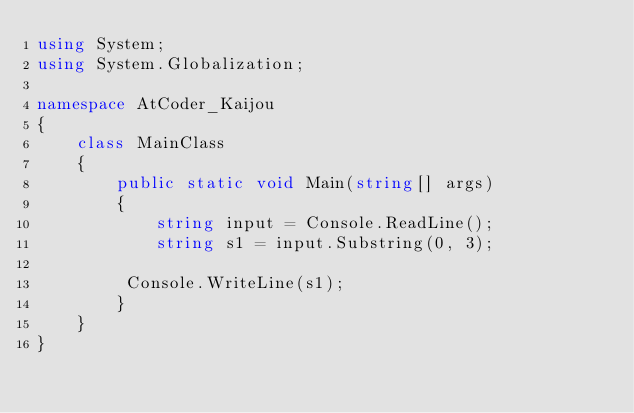Convert code to text. <code><loc_0><loc_0><loc_500><loc_500><_C#_>using System;
using System.Globalization;

namespace AtCoder_Kaijou
{
    class MainClass
    {
        public static void Main(string[] args)
        {
            string input = Console.ReadLine();
            string s1 = input.Substring(0, 3);

         Console.WriteLine(s1);
        }
    }
}
</code> 